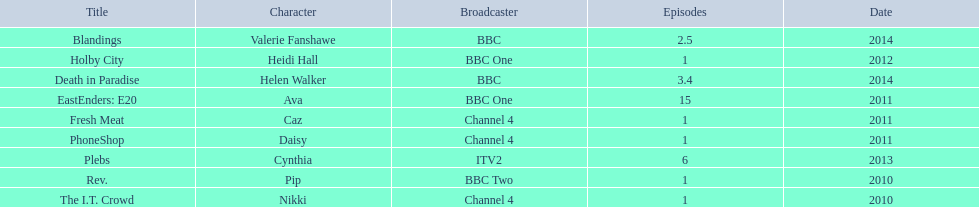What roles did she play? Pip, Nikki, Ava, Caz, Daisy, Heidi Hall, Cynthia, Valerie Fanshawe, Helen Walker. On which broadcasters? BBC Two, Channel 4, BBC One, Channel 4, Channel 4, BBC One, ITV2, BBC, BBC. Which roles did she play for itv2? Cynthia. 